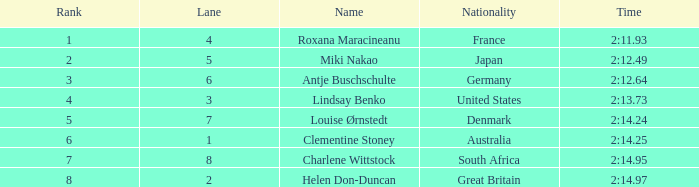For louise ørnstedt, what is the quantity of lanes possessing a rank exceeding 2? 1.0. 